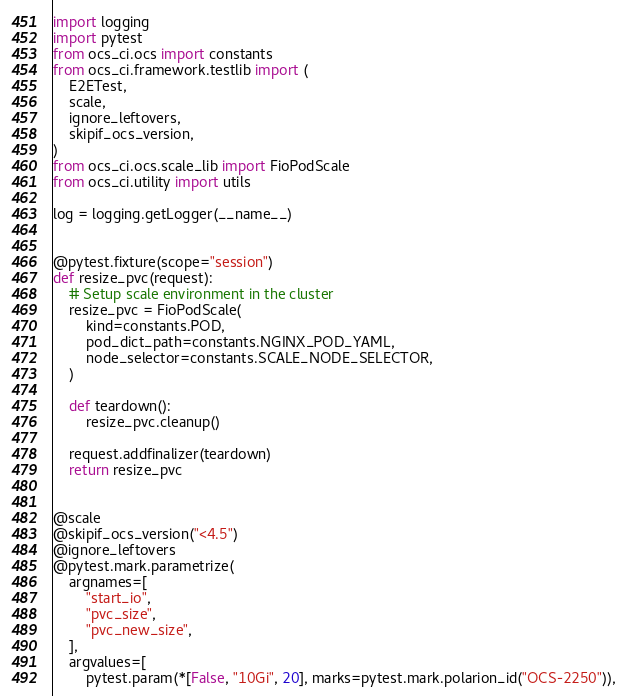Convert code to text. <code><loc_0><loc_0><loc_500><loc_500><_Python_>import logging
import pytest
from ocs_ci.ocs import constants
from ocs_ci.framework.testlib import (
    E2ETest,
    scale,
    ignore_leftovers,
    skipif_ocs_version,
)
from ocs_ci.ocs.scale_lib import FioPodScale
from ocs_ci.utility import utils

log = logging.getLogger(__name__)


@pytest.fixture(scope="session")
def resize_pvc(request):
    # Setup scale environment in the cluster
    resize_pvc = FioPodScale(
        kind=constants.POD,
        pod_dict_path=constants.NGINX_POD_YAML,
        node_selector=constants.SCALE_NODE_SELECTOR,
    )

    def teardown():
        resize_pvc.cleanup()

    request.addfinalizer(teardown)
    return resize_pvc


@scale
@skipif_ocs_version("<4.5")
@ignore_leftovers
@pytest.mark.parametrize(
    argnames=[
        "start_io",
        "pvc_size",
        "pvc_new_size",
    ],
    argvalues=[
        pytest.param(*[False, "10Gi", 20], marks=pytest.mark.polarion_id("OCS-2250")),</code> 